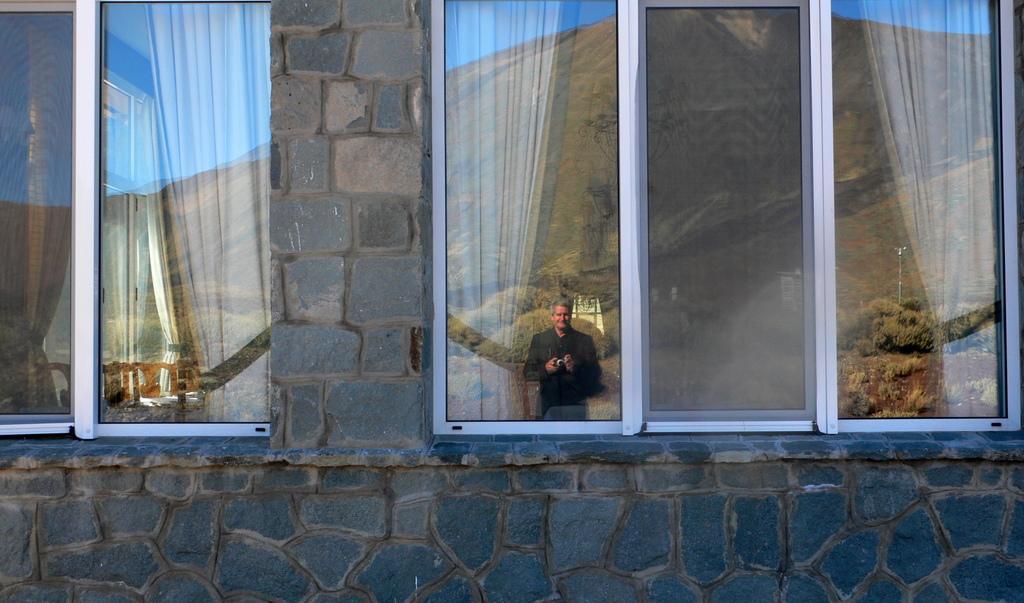Could you give a brief overview of what you see in this image? We can see wall and glass windows,through this glass windows we can see curtains and there is a man standing and holding camera,behind this man we can see trees,hill and sky. 